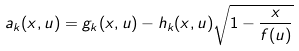Convert formula to latex. <formula><loc_0><loc_0><loc_500><loc_500>a _ { k } ( x , u ) = g _ { k } ( x , u ) - h _ { k } ( x , u ) \sqrt { 1 - \frac { x } { f ( u ) } }</formula> 